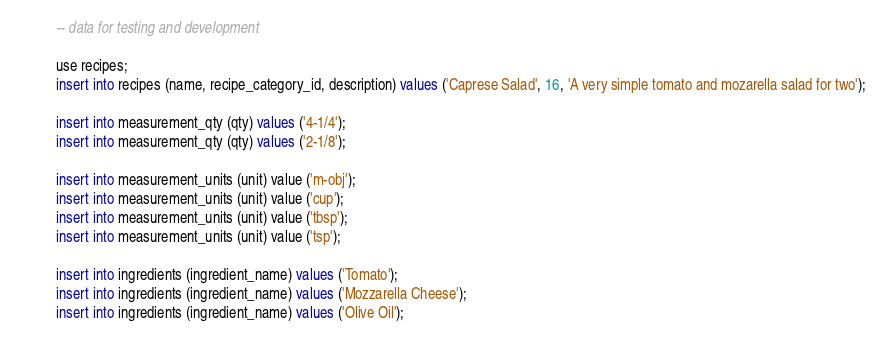<code> <loc_0><loc_0><loc_500><loc_500><_SQL_>-- data for testing and development

use recipes;
insert into recipes (name, recipe_category_id, description) values ('Caprese Salad', 16, 'A very simple tomato and mozarella salad for two');

insert into measurement_qty (qty) values ('4-1/4');
insert into measurement_qty (qty) values ('2-1/8');

insert into measurement_units (unit) value ('m-obj');
insert into measurement_units (unit) value ('cup');
insert into measurement_units (unit) value ('tbsp');
insert into measurement_units (unit) value ('tsp');

insert into ingredients (ingredient_name) values ('Tomato');
insert into ingredients (ingredient_name) values ('Mozzarella Cheese');
insert into ingredients (ingredient_name) values ('Olive Oil');</code> 